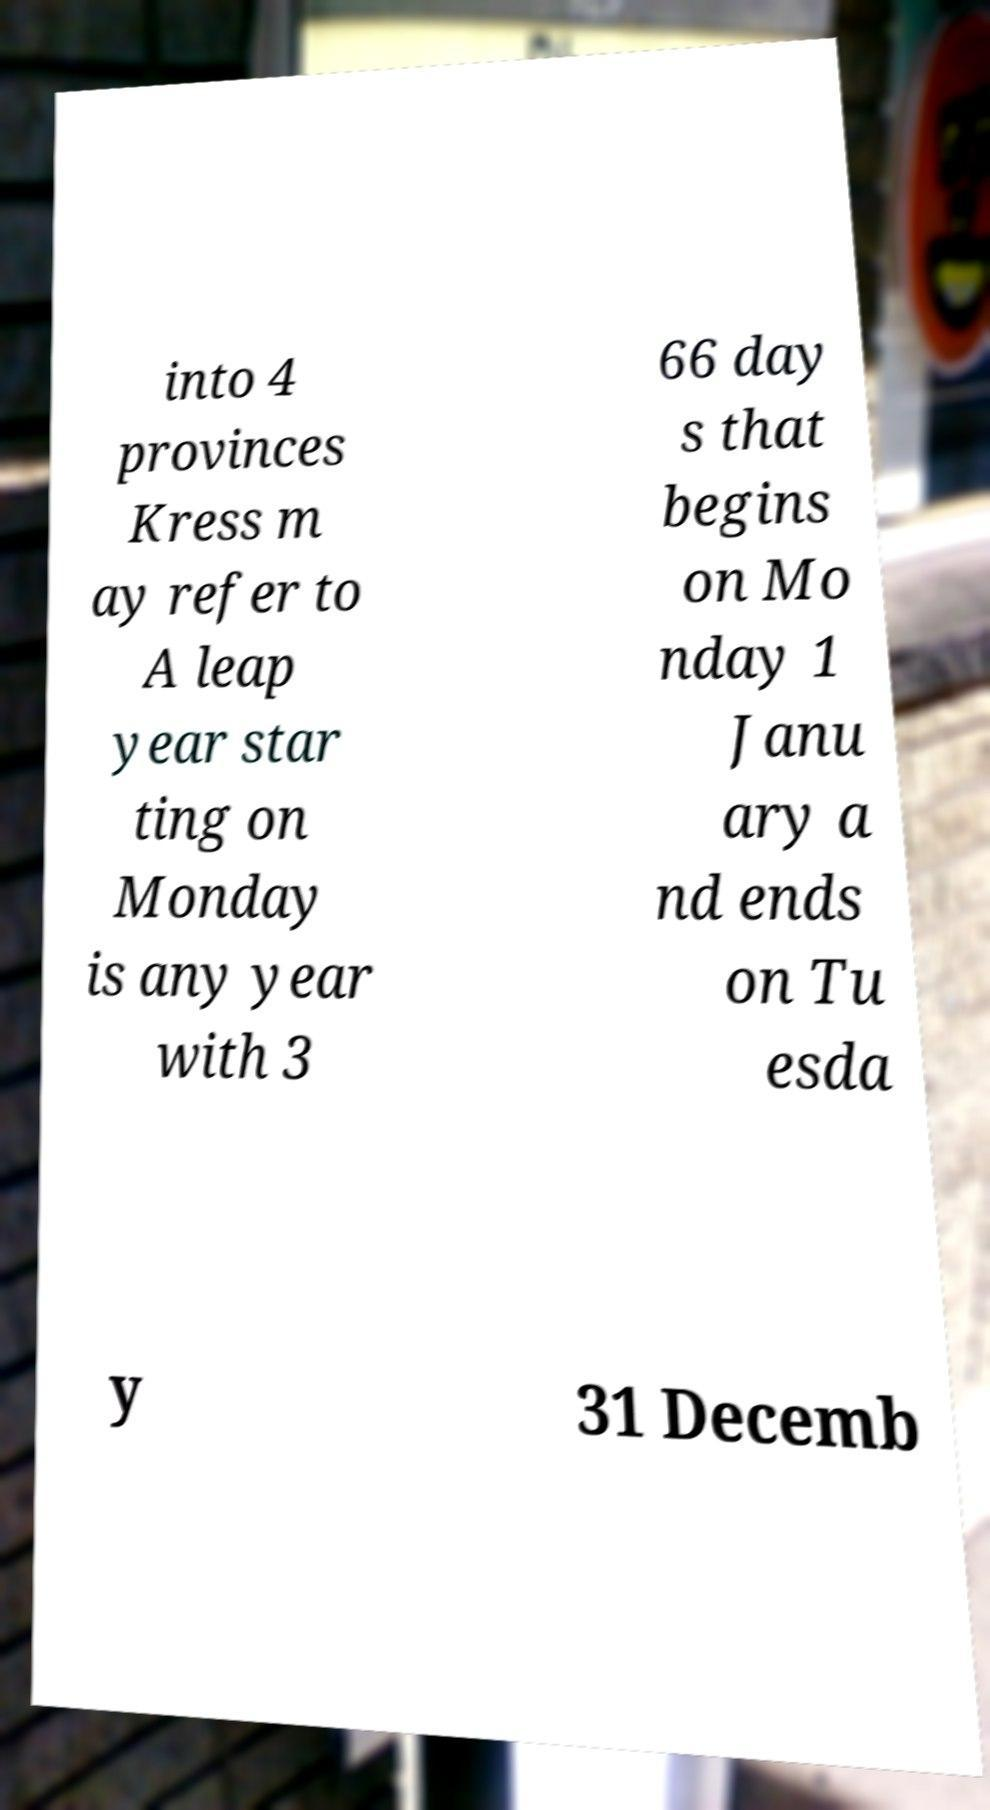Could you extract and type out the text from this image? into 4 provinces Kress m ay refer to A leap year star ting on Monday is any year with 3 66 day s that begins on Mo nday 1 Janu ary a nd ends on Tu esda y 31 Decemb 